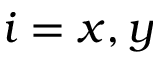<formula> <loc_0><loc_0><loc_500><loc_500>i = x , y</formula> 